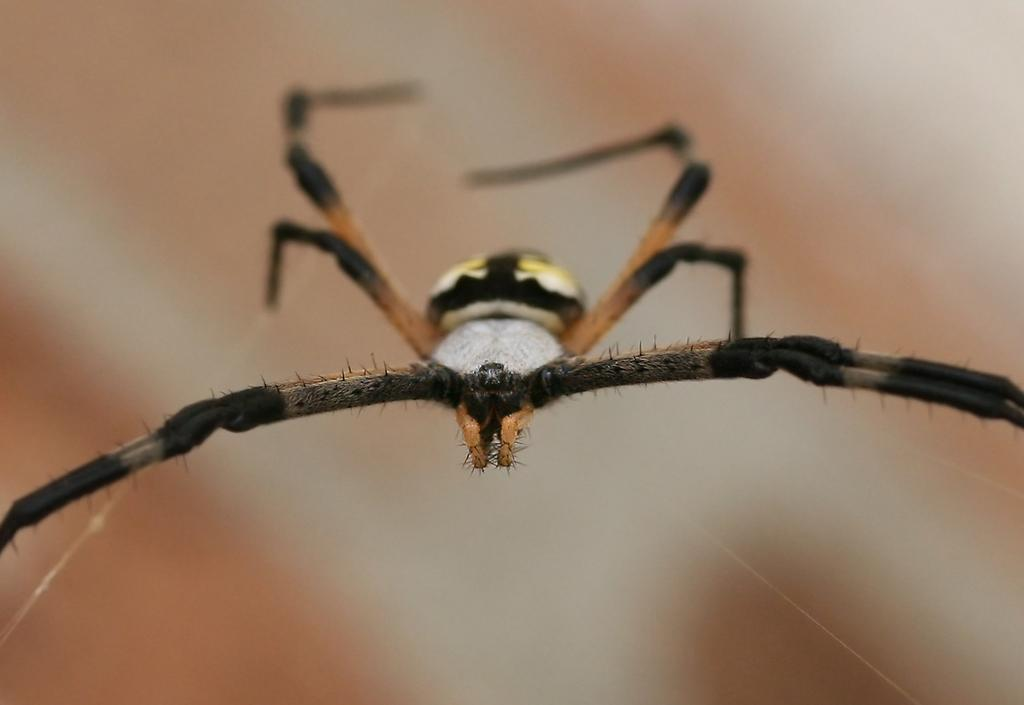What is the main subject of the image? There is a spider in the image. Can you describe the background of the image? The background of the image is blurred. What type of surprise can be seen in the stomach of the spider in the image? There is no surprise or stomach visible in the image, as it features a spider and a blurred background. 